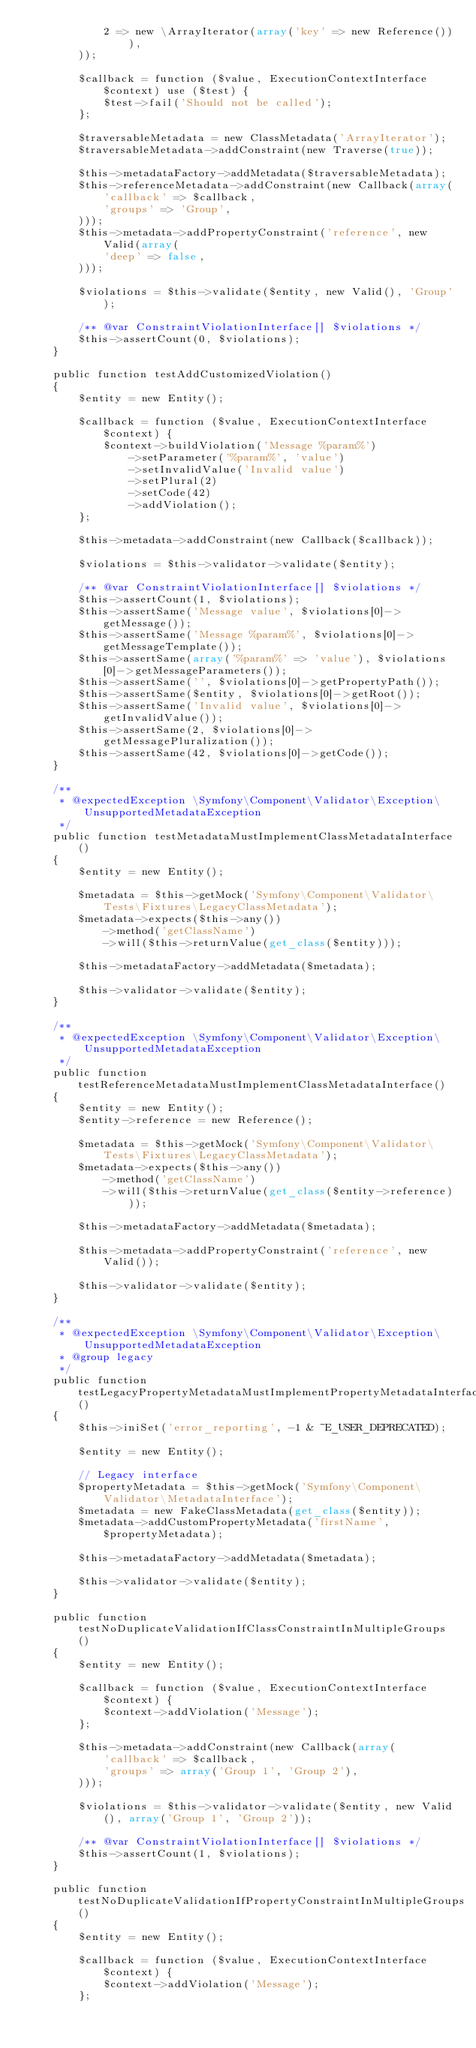Convert code to text. <code><loc_0><loc_0><loc_500><loc_500><_PHP_>            2 => new \ArrayIterator(array('key' => new Reference())),
        ));

        $callback = function ($value, ExecutionContextInterface $context) use ($test) {
            $test->fail('Should not be called');
        };

        $traversableMetadata = new ClassMetadata('ArrayIterator');
        $traversableMetadata->addConstraint(new Traverse(true));

        $this->metadataFactory->addMetadata($traversableMetadata);
        $this->referenceMetadata->addConstraint(new Callback(array(
            'callback' => $callback,
            'groups' => 'Group',
        )));
        $this->metadata->addPropertyConstraint('reference', new Valid(array(
            'deep' => false,
        )));

        $violations = $this->validate($entity, new Valid(), 'Group');

        /** @var ConstraintViolationInterface[] $violations */
        $this->assertCount(0, $violations);
    }

    public function testAddCustomizedViolation()
    {
        $entity = new Entity();

        $callback = function ($value, ExecutionContextInterface $context) {
            $context->buildViolation('Message %param%')
                ->setParameter('%param%', 'value')
                ->setInvalidValue('Invalid value')
                ->setPlural(2)
                ->setCode(42)
                ->addViolation();
        };

        $this->metadata->addConstraint(new Callback($callback));

        $violations = $this->validator->validate($entity);

        /** @var ConstraintViolationInterface[] $violations */
        $this->assertCount(1, $violations);
        $this->assertSame('Message value', $violations[0]->getMessage());
        $this->assertSame('Message %param%', $violations[0]->getMessageTemplate());
        $this->assertSame(array('%param%' => 'value'), $violations[0]->getMessageParameters());
        $this->assertSame('', $violations[0]->getPropertyPath());
        $this->assertSame($entity, $violations[0]->getRoot());
        $this->assertSame('Invalid value', $violations[0]->getInvalidValue());
        $this->assertSame(2, $violations[0]->getMessagePluralization());
        $this->assertSame(42, $violations[0]->getCode());
    }

    /**
     * @expectedException \Symfony\Component\Validator\Exception\UnsupportedMetadataException
     */
    public function testMetadataMustImplementClassMetadataInterface()
    {
        $entity = new Entity();

        $metadata = $this->getMock('Symfony\Component\Validator\Tests\Fixtures\LegacyClassMetadata');
        $metadata->expects($this->any())
            ->method('getClassName')
            ->will($this->returnValue(get_class($entity)));

        $this->metadataFactory->addMetadata($metadata);

        $this->validator->validate($entity);
    }

    /**
     * @expectedException \Symfony\Component\Validator\Exception\UnsupportedMetadataException
     */
    public function testReferenceMetadataMustImplementClassMetadataInterface()
    {
        $entity = new Entity();
        $entity->reference = new Reference();

        $metadata = $this->getMock('Symfony\Component\Validator\Tests\Fixtures\LegacyClassMetadata');
        $metadata->expects($this->any())
            ->method('getClassName')
            ->will($this->returnValue(get_class($entity->reference)));

        $this->metadataFactory->addMetadata($metadata);

        $this->metadata->addPropertyConstraint('reference', new Valid());

        $this->validator->validate($entity);
    }

    /**
     * @expectedException \Symfony\Component\Validator\Exception\UnsupportedMetadataException
     * @group legacy
     */
    public function testLegacyPropertyMetadataMustImplementPropertyMetadataInterface()
    {
        $this->iniSet('error_reporting', -1 & ~E_USER_DEPRECATED);

        $entity = new Entity();

        // Legacy interface
        $propertyMetadata = $this->getMock('Symfony\Component\Validator\MetadataInterface');
        $metadata = new FakeClassMetadata(get_class($entity));
        $metadata->addCustomPropertyMetadata('firstName', $propertyMetadata);

        $this->metadataFactory->addMetadata($metadata);

        $this->validator->validate($entity);
    }

    public function testNoDuplicateValidationIfClassConstraintInMultipleGroups()
    {
        $entity = new Entity();

        $callback = function ($value, ExecutionContextInterface $context) {
            $context->addViolation('Message');
        };

        $this->metadata->addConstraint(new Callback(array(
            'callback' => $callback,
            'groups' => array('Group 1', 'Group 2'),
        )));

        $violations = $this->validator->validate($entity, new Valid(), array('Group 1', 'Group 2'));

        /** @var ConstraintViolationInterface[] $violations */
        $this->assertCount(1, $violations);
    }

    public function testNoDuplicateValidationIfPropertyConstraintInMultipleGroups()
    {
        $entity = new Entity();

        $callback = function ($value, ExecutionContextInterface $context) {
            $context->addViolation('Message');
        };
</code> 